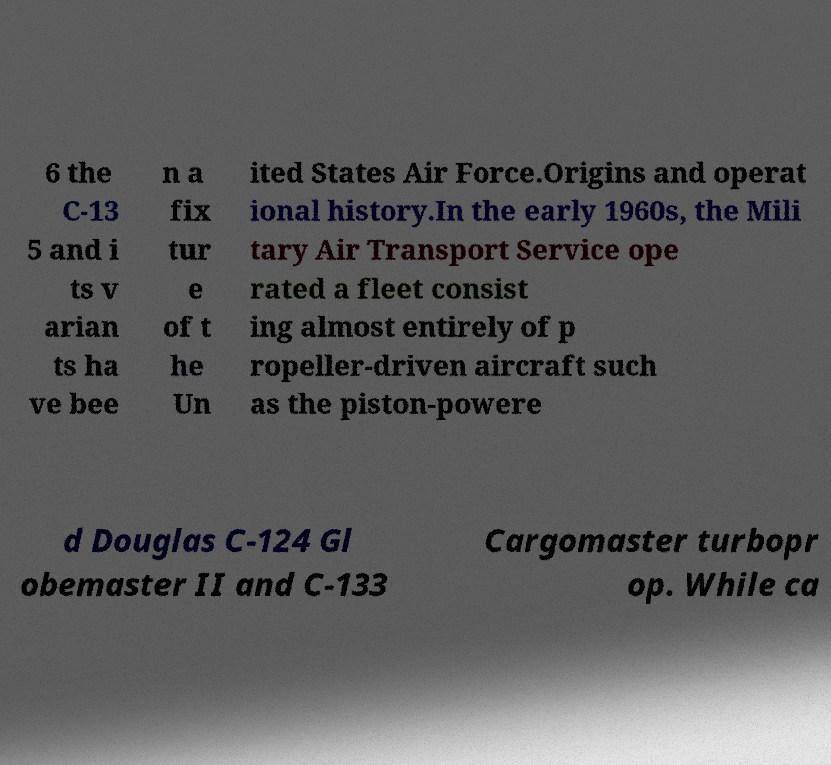I need the written content from this picture converted into text. Can you do that? 6 the C-13 5 and i ts v arian ts ha ve bee n a fix tur e of t he Un ited States Air Force.Origins and operat ional history.In the early 1960s, the Mili tary Air Transport Service ope rated a fleet consist ing almost entirely of p ropeller-driven aircraft such as the piston-powere d Douglas C-124 Gl obemaster II and C-133 Cargomaster turbopr op. While ca 